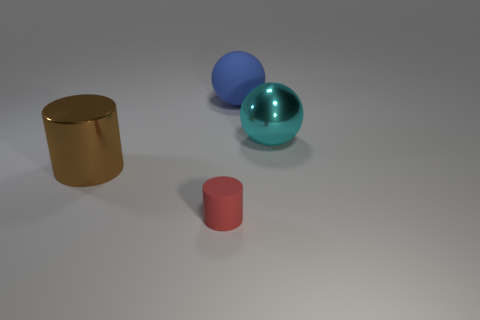Add 1 tiny red objects. How many objects exist? 5 Subtract all small purple rubber objects. Subtract all large rubber things. How many objects are left? 3 Add 4 big shiny cylinders. How many big shiny cylinders are left? 5 Add 3 big things. How many big things exist? 6 Subtract 0 purple balls. How many objects are left? 4 